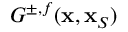<formula> <loc_0><loc_0><loc_500><loc_500>G ^ { \pm , f } ( { x } , { x } _ { S } )</formula> 